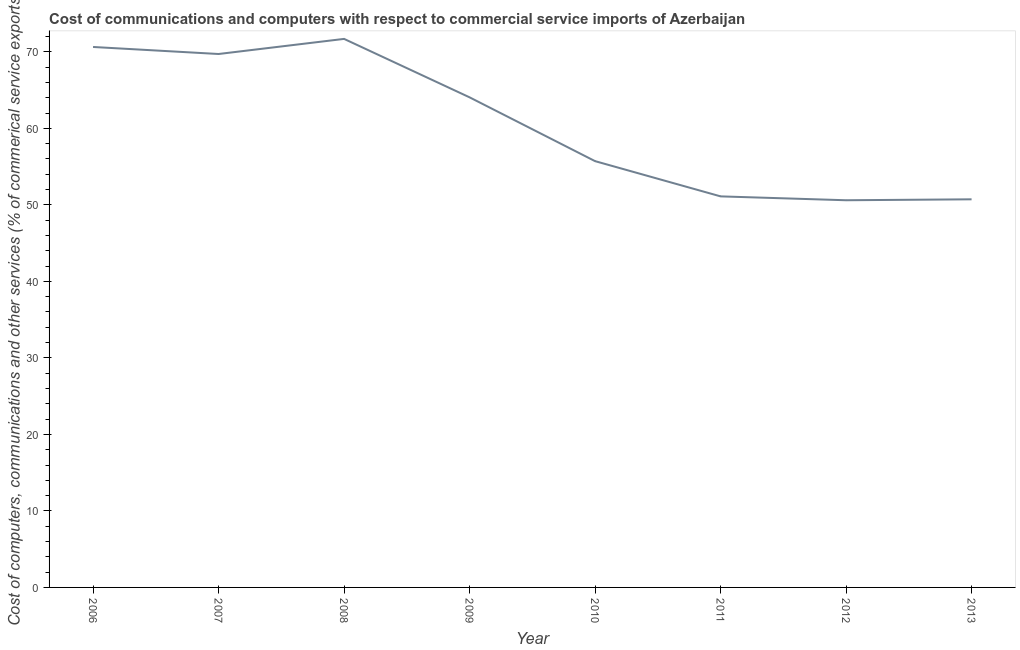What is the cost of communications in 2009?
Provide a succinct answer. 64.05. Across all years, what is the maximum cost of communications?
Your answer should be very brief. 71.69. Across all years, what is the minimum cost of communications?
Offer a terse response. 50.6. What is the sum of the  computer and other services?
Your response must be concise. 484.24. What is the difference between the cost of communications in 2011 and 2013?
Keep it short and to the point. 0.39. What is the average cost of communications per year?
Offer a very short reply. 60.53. What is the median cost of communications?
Give a very brief answer. 59.88. In how many years, is the  computer and other services greater than 16 %?
Offer a very short reply. 8. Do a majority of the years between 2009 and 2007 (inclusive) have cost of communications greater than 42 %?
Offer a very short reply. No. What is the ratio of the  computer and other services in 2006 to that in 2010?
Offer a very short reply. 1.27. Is the difference between the cost of communications in 2006 and 2012 greater than the difference between any two years?
Ensure brevity in your answer.  No. What is the difference between the highest and the second highest cost of communications?
Provide a succinct answer. 1.05. What is the difference between the highest and the lowest cost of communications?
Provide a short and direct response. 21.09. How many lines are there?
Offer a very short reply. 1. Does the graph contain any zero values?
Your answer should be compact. No. What is the title of the graph?
Keep it short and to the point. Cost of communications and computers with respect to commercial service imports of Azerbaijan. What is the label or title of the Y-axis?
Offer a terse response. Cost of computers, communications and other services (% of commerical service exports). What is the Cost of computers, communications and other services (% of commerical service exports) in 2006?
Ensure brevity in your answer.  70.64. What is the Cost of computers, communications and other services (% of commerical service exports) of 2007?
Your answer should be very brief. 69.72. What is the Cost of computers, communications and other services (% of commerical service exports) in 2008?
Your answer should be very brief. 71.69. What is the Cost of computers, communications and other services (% of commerical service exports) of 2009?
Make the answer very short. 64.05. What is the Cost of computers, communications and other services (% of commerical service exports) in 2010?
Your answer should be compact. 55.71. What is the Cost of computers, communications and other services (% of commerical service exports) of 2011?
Provide a short and direct response. 51.11. What is the Cost of computers, communications and other services (% of commerical service exports) in 2012?
Offer a very short reply. 50.6. What is the Cost of computers, communications and other services (% of commerical service exports) in 2013?
Ensure brevity in your answer.  50.72. What is the difference between the Cost of computers, communications and other services (% of commerical service exports) in 2006 and 2007?
Make the answer very short. 0.92. What is the difference between the Cost of computers, communications and other services (% of commerical service exports) in 2006 and 2008?
Your answer should be very brief. -1.05. What is the difference between the Cost of computers, communications and other services (% of commerical service exports) in 2006 and 2009?
Give a very brief answer. 6.58. What is the difference between the Cost of computers, communications and other services (% of commerical service exports) in 2006 and 2010?
Provide a short and direct response. 14.92. What is the difference between the Cost of computers, communications and other services (% of commerical service exports) in 2006 and 2011?
Give a very brief answer. 19.53. What is the difference between the Cost of computers, communications and other services (% of commerical service exports) in 2006 and 2012?
Give a very brief answer. 20.03. What is the difference between the Cost of computers, communications and other services (% of commerical service exports) in 2006 and 2013?
Ensure brevity in your answer.  19.91. What is the difference between the Cost of computers, communications and other services (% of commerical service exports) in 2007 and 2008?
Your response must be concise. -1.97. What is the difference between the Cost of computers, communications and other services (% of commerical service exports) in 2007 and 2009?
Offer a terse response. 5.66. What is the difference between the Cost of computers, communications and other services (% of commerical service exports) in 2007 and 2010?
Your answer should be very brief. 14. What is the difference between the Cost of computers, communications and other services (% of commerical service exports) in 2007 and 2011?
Ensure brevity in your answer.  18.61. What is the difference between the Cost of computers, communications and other services (% of commerical service exports) in 2007 and 2012?
Your response must be concise. 19.11. What is the difference between the Cost of computers, communications and other services (% of commerical service exports) in 2007 and 2013?
Provide a short and direct response. 18.99. What is the difference between the Cost of computers, communications and other services (% of commerical service exports) in 2008 and 2009?
Offer a very short reply. 7.64. What is the difference between the Cost of computers, communications and other services (% of commerical service exports) in 2008 and 2010?
Keep it short and to the point. 15.98. What is the difference between the Cost of computers, communications and other services (% of commerical service exports) in 2008 and 2011?
Your answer should be very brief. 20.58. What is the difference between the Cost of computers, communications and other services (% of commerical service exports) in 2008 and 2012?
Make the answer very short. 21.09. What is the difference between the Cost of computers, communications and other services (% of commerical service exports) in 2008 and 2013?
Offer a terse response. 20.97. What is the difference between the Cost of computers, communications and other services (% of commerical service exports) in 2009 and 2010?
Your answer should be compact. 8.34. What is the difference between the Cost of computers, communications and other services (% of commerical service exports) in 2009 and 2011?
Keep it short and to the point. 12.94. What is the difference between the Cost of computers, communications and other services (% of commerical service exports) in 2009 and 2012?
Your answer should be compact. 13.45. What is the difference between the Cost of computers, communications and other services (% of commerical service exports) in 2009 and 2013?
Offer a very short reply. 13.33. What is the difference between the Cost of computers, communications and other services (% of commerical service exports) in 2010 and 2011?
Offer a terse response. 4.6. What is the difference between the Cost of computers, communications and other services (% of commerical service exports) in 2010 and 2012?
Offer a very short reply. 5.11. What is the difference between the Cost of computers, communications and other services (% of commerical service exports) in 2010 and 2013?
Offer a very short reply. 4.99. What is the difference between the Cost of computers, communications and other services (% of commerical service exports) in 2011 and 2012?
Make the answer very short. 0.51. What is the difference between the Cost of computers, communications and other services (% of commerical service exports) in 2011 and 2013?
Offer a very short reply. 0.39. What is the difference between the Cost of computers, communications and other services (% of commerical service exports) in 2012 and 2013?
Your answer should be very brief. -0.12. What is the ratio of the Cost of computers, communications and other services (% of commerical service exports) in 2006 to that in 2008?
Provide a succinct answer. 0.98. What is the ratio of the Cost of computers, communications and other services (% of commerical service exports) in 2006 to that in 2009?
Offer a very short reply. 1.1. What is the ratio of the Cost of computers, communications and other services (% of commerical service exports) in 2006 to that in 2010?
Keep it short and to the point. 1.27. What is the ratio of the Cost of computers, communications and other services (% of commerical service exports) in 2006 to that in 2011?
Offer a very short reply. 1.38. What is the ratio of the Cost of computers, communications and other services (% of commerical service exports) in 2006 to that in 2012?
Offer a very short reply. 1.4. What is the ratio of the Cost of computers, communications and other services (% of commerical service exports) in 2006 to that in 2013?
Offer a very short reply. 1.39. What is the ratio of the Cost of computers, communications and other services (% of commerical service exports) in 2007 to that in 2009?
Offer a terse response. 1.09. What is the ratio of the Cost of computers, communications and other services (% of commerical service exports) in 2007 to that in 2010?
Provide a succinct answer. 1.25. What is the ratio of the Cost of computers, communications and other services (% of commerical service exports) in 2007 to that in 2011?
Provide a short and direct response. 1.36. What is the ratio of the Cost of computers, communications and other services (% of commerical service exports) in 2007 to that in 2012?
Make the answer very short. 1.38. What is the ratio of the Cost of computers, communications and other services (% of commerical service exports) in 2007 to that in 2013?
Your answer should be compact. 1.37. What is the ratio of the Cost of computers, communications and other services (% of commerical service exports) in 2008 to that in 2009?
Provide a succinct answer. 1.12. What is the ratio of the Cost of computers, communications and other services (% of commerical service exports) in 2008 to that in 2010?
Your answer should be very brief. 1.29. What is the ratio of the Cost of computers, communications and other services (% of commerical service exports) in 2008 to that in 2011?
Provide a succinct answer. 1.4. What is the ratio of the Cost of computers, communications and other services (% of commerical service exports) in 2008 to that in 2012?
Ensure brevity in your answer.  1.42. What is the ratio of the Cost of computers, communications and other services (% of commerical service exports) in 2008 to that in 2013?
Your answer should be compact. 1.41. What is the ratio of the Cost of computers, communications and other services (% of commerical service exports) in 2009 to that in 2010?
Keep it short and to the point. 1.15. What is the ratio of the Cost of computers, communications and other services (% of commerical service exports) in 2009 to that in 2011?
Offer a very short reply. 1.25. What is the ratio of the Cost of computers, communications and other services (% of commerical service exports) in 2009 to that in 2012?
Your answer should be compact. 1.27. What is the ratio of the Cost of computers, communications and other services (% of commerical service exports) in 2009 to that in 2013?
Provide a succinct answer. 1.26. What is the ratio of the Cost of computers, communications and other services (% of commerical service exports) in 2010 to that in 2011?
Offer a very short reply. 1.09. What is the ratio of the Cost of computers, communications and other services (% of commerical service exports) in 2010 to that in 2012?
Provide a succinct answer. 1.1. What is the ratio of the Cost of computers, communications and other services (% of commerical service exports) in 2010 to that in 2013?
Ensure brevity in your answer.  1.1. What is the ratio of the Cost of computers, communications and other services (% of commerical service exports) in 2011 to that in 2013?
Your answer should be very brief. 1.01. What is the ratio of the Cost of computers, communications and other services (% of commerical service exports) in 2012 to that in 2013?
Offer a terse response. 1. 